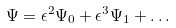<formula> <loc_0><loc_0><loc_500><loc_500>\Psi = \epsilon ^ { 2 } \Psi _ { 0 } + \epsilon ^ { 3 } \Psi _ { 1 } + \dots</formula> 